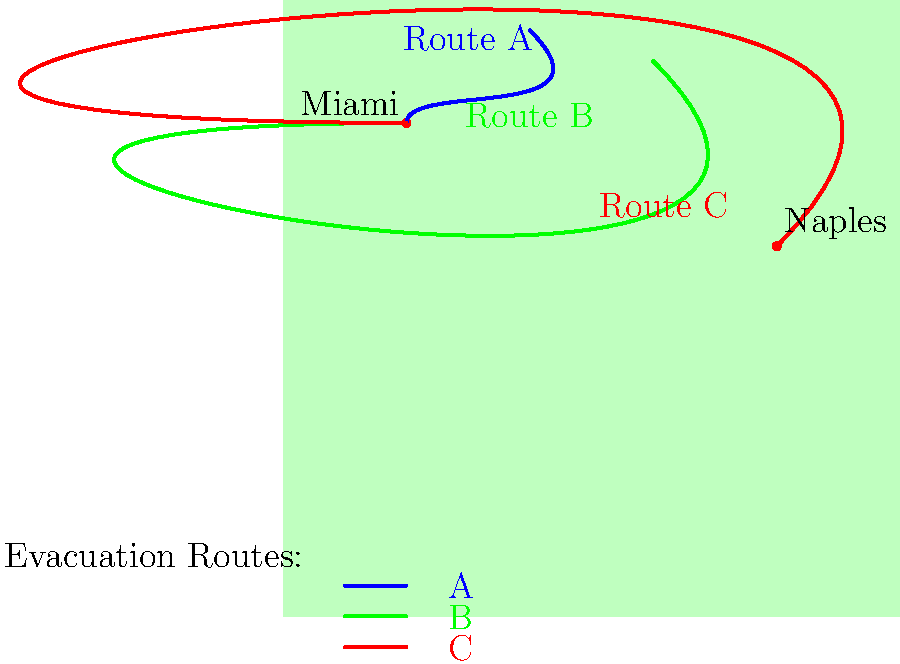As a pregnant woman preparing for hurricane season in South Florida, which evacuation route from Miami offers the safest and most efficient path considering your condition? To determine the safest and most efficient evacuation route for a pregnant woman in South Florida, we need to consider several factors:

1. Distance: Shorter routes are generally preferable to minimize travel time and discomfort.
2. Direction: Routes leading away from the coast are safer due to reduced flood risk.
3. Destination: Areas less prone to hurricane impacts are ideal.
4. Road conditions: Wider, more developed roads are safer and easier to navigate.

Analyzing the given routes:

Route A (Blue):
- Heads north, which is good for avoiding coastal flooding.
- Relatively short distance.
- May lead to areas still affected by the hurricane.

Route B (Green):
- Heads northwest, balancing distance from the coast with efficient travel.
- Moderate distance.
- Leads to inland areas that may be safer from hurricane effects.

Route C (Red):
- Heads west, then southwest towards Naples.
- Longest route among the options.
- Ends near another coastal city, which may still be in the hurricane's path.

Considering these factors, Route B (Green) appears to be the safest and most efficient option for a pregnant woman:
1. It provides a good balance between distance from the coast and travel efficiency.
2. The northwestern direction leads to inland areas that are typically safer from hurricane impacts.
3. The moderate distance is manageable for a pregnant woman, reducing travel time and associated discomfort.
4. It avoids the potential congestion of northbound routes (like Route A) that many evacuees might choose.
Answer: Route B (Green) 